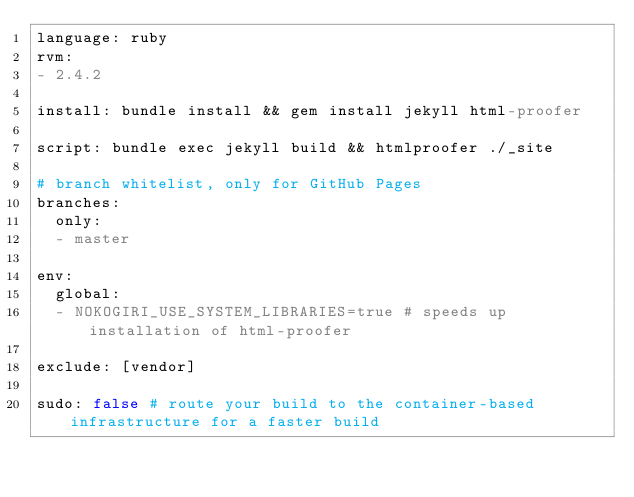Convert code to text. <code><loc_0><loc_0><loc_500><loc_500><_YAML_>language: ruby
rvm:
- 2.4.2

install: bundle install && gem install jekyll html-proofer

script: bundle exec jekyll build && htmlproofer ./_site

# branch whitelist, only for GitHub Pages
branches:
  only:
  - master

env:
  global:
  - NOKOGIRI_USE_SYSTEM_LIBRARIES=true # speeds up installation of html-proofer

exclude: [vendor]

sudo: false # route your build to the container-based infrastructure for a faster build
</code> 